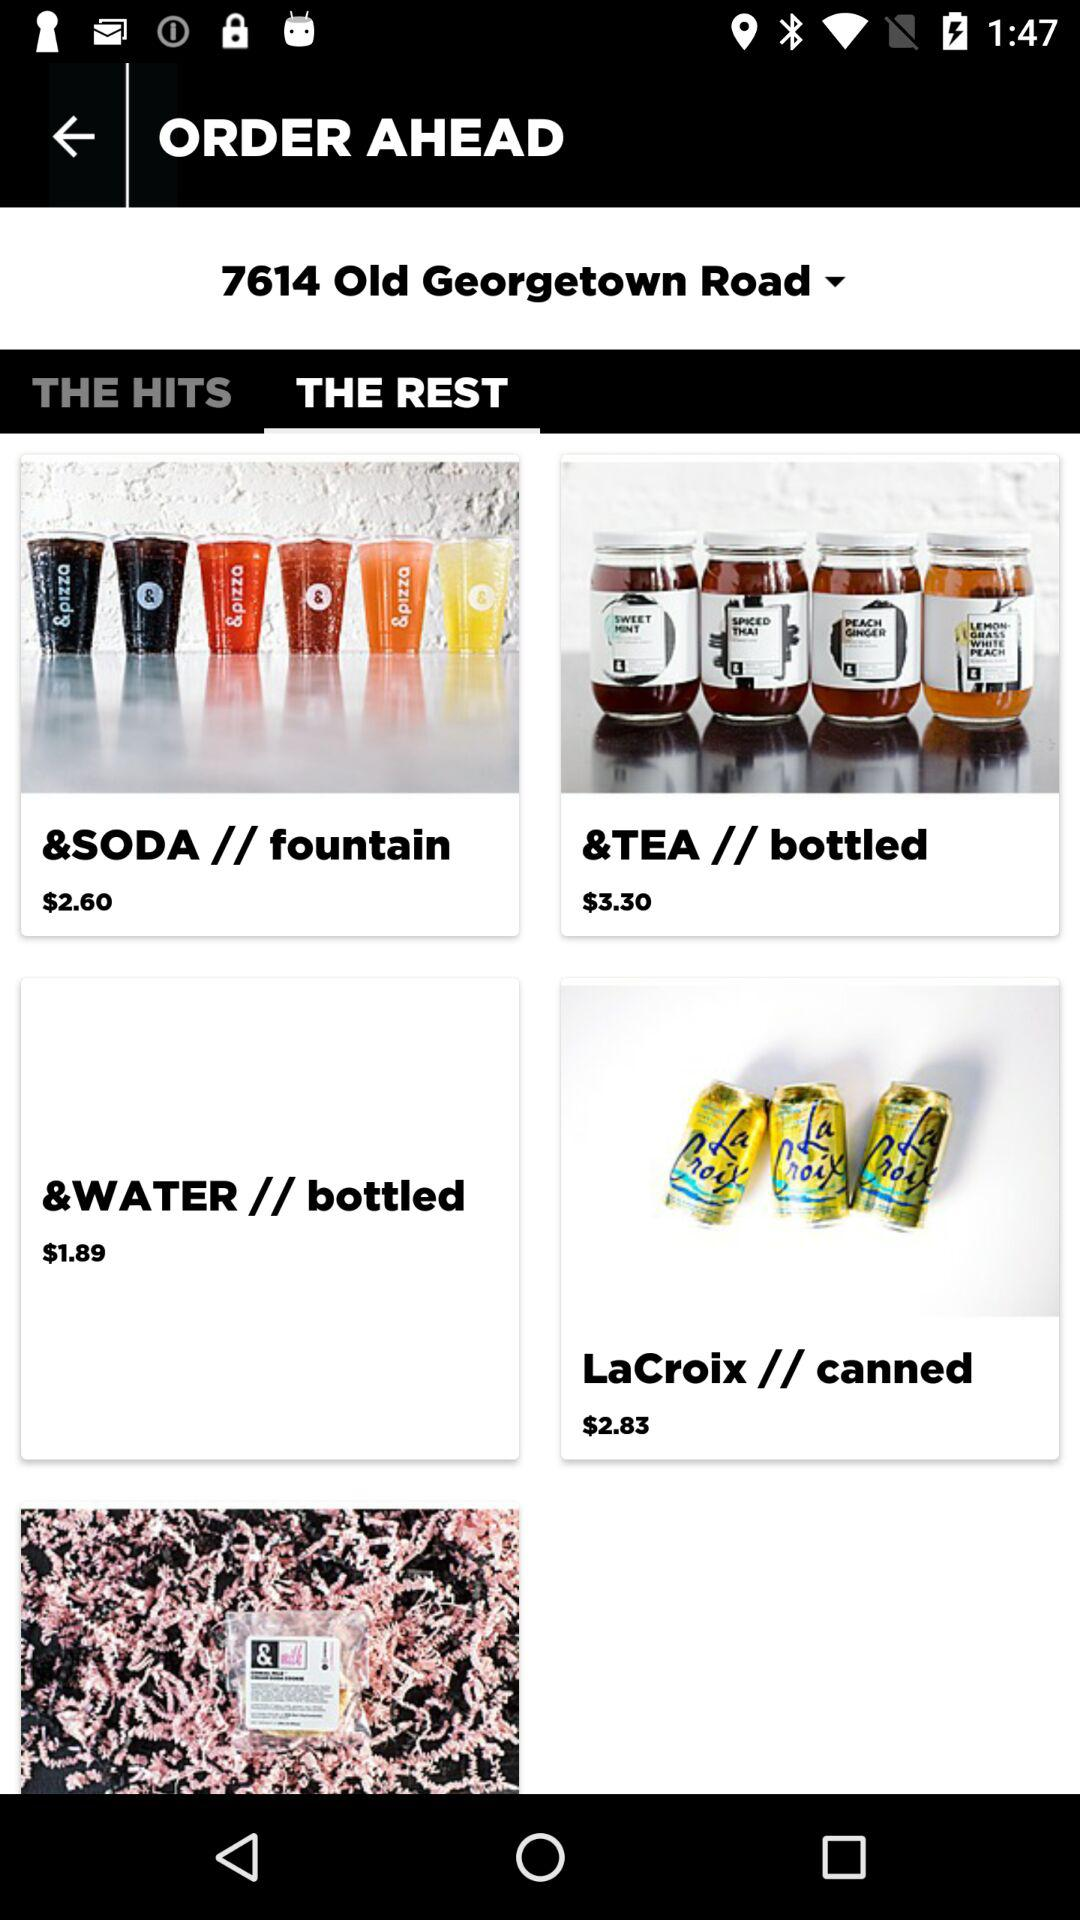How much does the "&WATER // bottled" cost? The price is $1.89. 